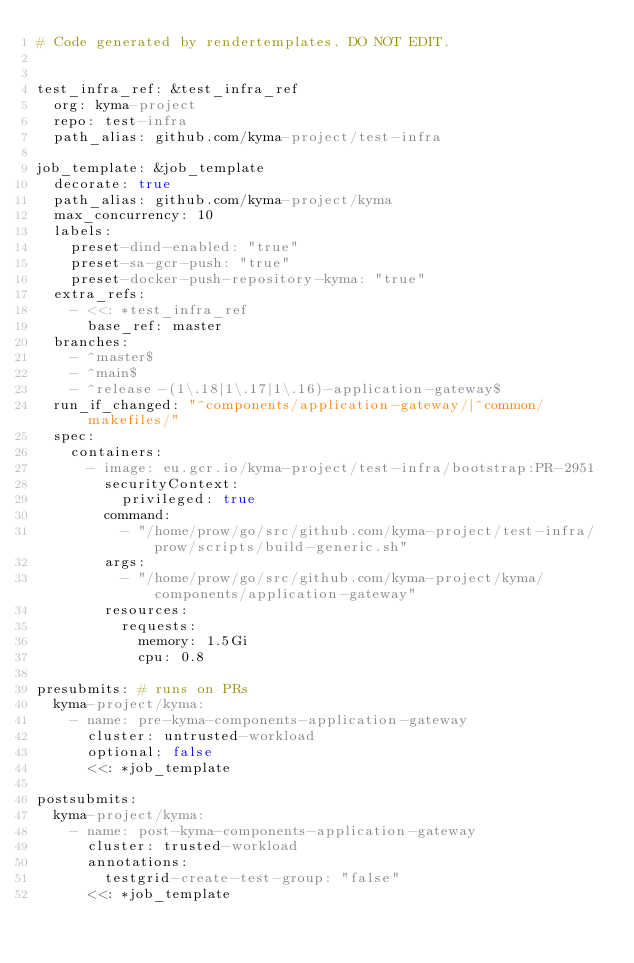<code> <loc_0><loc_0><loc_500><loc_500><_YAML_># Code generated by rendertemplates. DO NOT EDIT.


test_infra_ref: &test_infra_ref
  org: kyma-project
  repo: test-infra
  path_alias: github.com/kyma-project/test-infra

job_template: &job_template
  decorate: true
  path_alias: github.com/kyma-project/kyma
  max_concurrency: 10
  labels:
    preset-dind-enabled: "true"
    preset-sa-gcr-push: "true"
    preset-docker-push-repository-kyma: "true"
  extra_refs:
    - <<: *test_infra_ref
      base_ref: master
  branches:
    - ^master$
    - ^main$
    - ^release-(1\.18|1\.17|1\.16)-application-gateway$
  run_if_changed: "^components/application-gateway/|^common/makefiles/"
  spec:
    containers:
      - image: eu.gcr.io/kyma-project/test-infra/bootstrap:PR-2951
        securityContext:
          privileged: true
        command:
          - "/home/prow/go/src/github.com/kyma-project/test-infra/prow/scripts/build-generic.sh"
        args:
          - "/home/prow/go/src/github.com/kyma-project/kyma/components/application-gateway"
        resources:
          requests:
            memory: 1.5Gi
            cpu: 0.8

presubmits: # runs on PRs
  kyma-project/kyma:
    - name: pre-kyma-components-application-gateway
      cluster: untrusted-workload
      optional: false
      <<: *job_template

postsubmits:
  kyma-project/kyma:
    - name: post-kyma-components-application-gateway
      cluster: trusted-workload
      annotations:
        testgrid-create-test-group: "false"
      <<: *job_template
</code> 